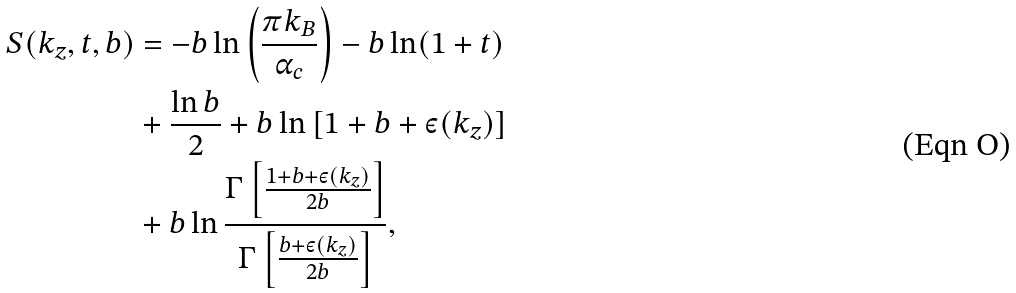<formula> <loc_0><loc_0><loc_500><loc_500>S ( k _ { z } , t , b ) & = - b \ln \left ( \frac { \pi k _ { B } } { \alpha _ { c } } \right ) - b \ln ( 1 + t ) \\ & + \frac { \ln b } { 2 } + b \ln \left [ 1 + b + \varepsilon ( k _ { z } ) \right ] \\ & + b \ln \frac { \Gamma \left [ \frac { 1 + b + \varepsilon ( k _ { z } ) } { 2 b } \right ] } { \Gamma \left [ \frac { b + \varepsilon ( k _ { z } ) } { 2 b } \right ] } ,</formula> 